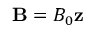<formula> <loc_0><loc_0><loc_500><loc_500>{ B } = B _ { 0 } { z }</formula> 